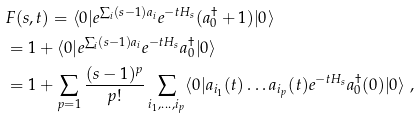Convert formula to latex. <formula><loc_0><loc_0><loc_500><loc_500>& F ( s , t ) = \langle 0 | e ^ { \sum _ { i } ( s - 1 ) a _ { i } } e ^ { - t H _ { s } } ( a ^ { \dag } _ { 0 } + 1 ) | 0 \rangle \\ & = 1 + \langle 0 | e ^ { \sum _ { i } ( s - 1 ) a _ { i } } e ^ { - t H _ { s } } a ^ { \dag } _ { 0 } | 0 \rangle \\ & = 1 + \sum _ { p = 1 } \frac { ( s - 1 ) ^ { p } } { p ! } \sum _ { i _ { 1 } , \dots , i _ { p } } \langle 0 | a _ { i _ { 1 } } ( t ) \dots a _ { i _ { p } } ( t ) e ^ { - t H _ { s } } a ^ { \dag } _ { 0 } ( 0 ) | 0 \rangle \ ,</formula> 